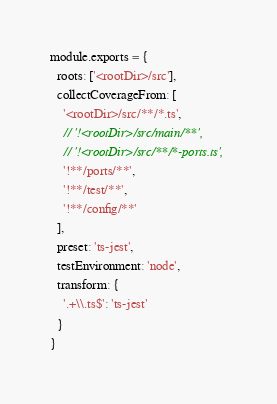Convert code to text. <code><loc_0><loc_0><loc_500><loc_500><_JavaScript_>module.exports = {
  roots: ['<rootDir>/src'],
  collectCoverageFrom: [
    '<rootDir>/src/**/*.ts',
    // '!<rootDir>/src/main/**',
    // '!<rootDir>/src/**/*-ports.ts',
    '!**/ports/**',
    '!**/test/**',
    '!**/config/**'
  ],
  preset: 'ts-jest',
  testEnvironment: 'node',
  transform: {
    '.+\\.ts$': 'ts-jest'
  }
}</code> 